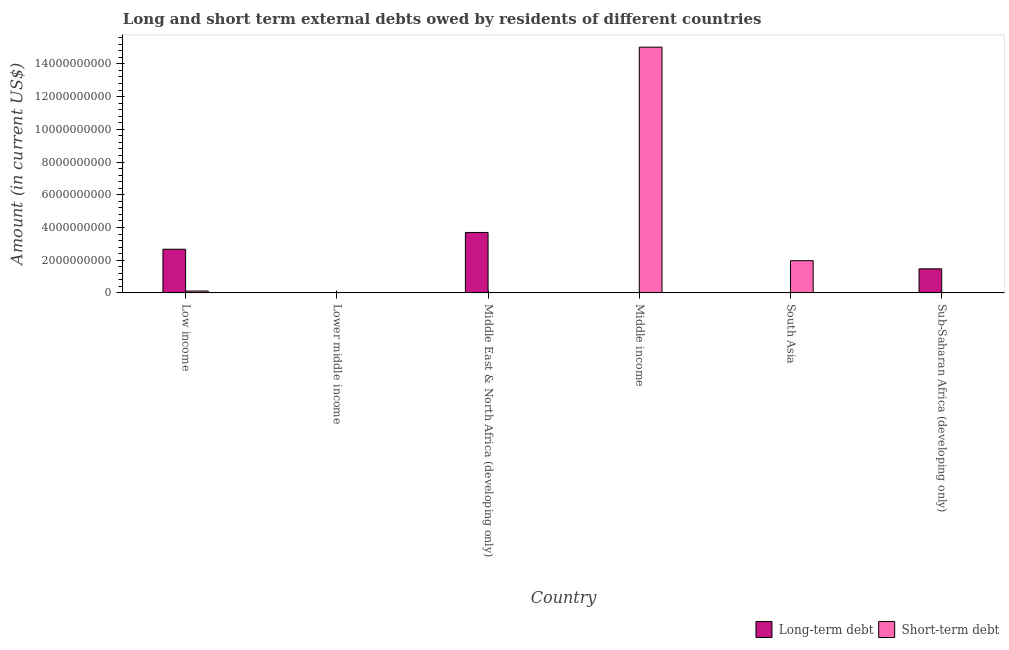How many different coloured bars are there?
Your answer should be compact. 2. Are the number of bars per tick equal to the number of legend labels?
Provide a succinct answer. No. How many bars are there on the 3rd tick from the right?
Provide a short and direct response. 1. In how many cases, is the number of bars for a given country not equal to the number of legend labels?
Make the answer very short. 5. What is the short-term debts owed by residents in Low income?
Keep it short and to the point. 1.17e+08. Across all countries, what is the maximum short-term debts owed by residents?
Keep it short and to the point. 1.50e+1. In which country was the short-term debts owed by residents maximum?
Your answer should be compact. Middle income. What is the total long-term debts owed by residents in the graph?
Offer a very short reply. 7.84e+09. What is the difference between the short-term debts owed by residents in Middle income and that in South Asia?
Ensure brevity in your answer.  1.30e+1. What is the difference between the short-term debts owed by residents in Lower middle income and the long-term debts owed by residents in South Asia?
Provide a short and direct response. 0. What is the average short-term debts owed by residents per country?
Provide a succinct answer. 2.85e+09. What is the difference between the short-term debts owed by residents and long-term debts owed by residents in Low income?
Keep it short and to the point. -2.55e+09. What is the ratio of the long-term debts owed by residents in Middle East & North Africa (developing only) to that in Sub-Saharan Africa (developing only)?
Your answer should be very brief. 2.51. What is the difference between the highest and the second highest long-term debts owed by residents?
Make the answer very short. 1.03e+09. What is the difference between the highest and the lowest short-term debts owed by residents?
Provide a short and direct response. 1.50e+1. Is the sum of the short-term debts owed by residents in Low income and South Asia greater than the maximum long-term debts owed by residents across all countries?
Offer a very short reply. No. How many countries are there in the graph?
Your response must be concise. 6. What is the difference between two consecutive major ticks on the Y-axis?
Ensure brevity in your answer.  2.00e+09. Are the values on the major ticks of Y-axis written in scientific E-notation?
Keep it short and to the point. No. Does the graph contain any zero values?
Ensure brevity in your answer.  Yes. What is the title of the graph?
Keep it short and to the point. Long and short term external debts owed by residents of different countries. What is the label or title of the X-axis?
Provide a short and direct response. Country. What is the Amount (in current US$) in Long-term debt in Low income?
Keep it short and to the point. 2.67e+09. What is the Amount (in current US$) in Short-term debt in Low income?
Keep it short and to the point. 1.17e+08. What is the Amount (in current US$) in Short-term debt in Lower middle income?
Your response must be concise. 0. What is the Amount (in current US$) in Long-term debt in Middle East & North Africa (developing only)?
Make the answer very short. 3.70e+09. What is the Amount (in current US$) in Short-term debt in Middle income?
Your response must be concise. 1.50e+1. What is the Amount (in current US$) of Short-term debt in South Asia?
Offer a very short reply. 1.97e+09. What is the Amount (in current US$) in Long-term debt in Sub-Saharan Africa (developing only)?
Ensure brevity in your answer.  1.47e+09. Across all countries, what is the maximum Amount (in current US$) of Long-term debt?
Provide a short and direct response. 3.70e+09. Across all countries, what is the maximum Amount (in current US$) of Short-term debt?
Make the answer very short. 1.50e+1. Across all countries, what is the minimum Amount (in current US$) in Long-term debt?
Keep it short and to the point. 0. What is the total Amount (in current US$) in Long-term debt in the graph?
Provide a succinct answer. 7.84e+09. What is the total Amount (in current US$) in Short-term debt in the graph?
Offer a very short reply. 1.71e+1. What is the difference between the Amount (in current US$) of Long-term debt in Low income and that in Middle East & North Africa (developing only)?
Your response must be concise. -1.03e+09. What is the difference between the Amount (in current US$) of Short-term debt in Low income and that in Middle income?
Provide a succinct answer. -1.49e+1. What is the difference between the Amount (in current US$) in Short-term debt in Low income and that in South Asia?
Your response must be concise. -1.85e+09. What is the difference between the Amount (in current US$) of Long-term debt in Low income and that in Sub-Saharan Africa (developing only)?
Give a very brief answer. 1.20e+09. What is the difference between the Amount (in current US$) of Long-term debt in Middle East & North Africa (developing only) and that in Sub-Saharan Africa (developing only)?
Keep it short and to the point. 2.22e+09. What is the difference between the Amount (in current US$) of Short-term debt in Middle income and that in South Asia?
Your response must be concise. 1.30e+1. What is the difference between the Amount (in current US$) of Long-term debt in Low income and the Amount (in current US$) of Short-term debt in Middle income?
Keep it short and to the point. -1.23e+1. What is the difference between the Amount (in current US$) in Long-term debt in Low income and the Amount (in current US$) in Short-term debt in South Asia?
Provide a short and direct response. 7.00e+08. What is the difference between the Amount (in current US$) of Long-term debt in Middle East & North Africa (developing only) and the Amount (in current US$) of Short-term debt in Middle income?
Offer a very short reply. -1.13e+1. What is the difference between the Amount (in current US$) of Long-term debt in Middle East & North Africa (developing only) and the Amount (in current US$) of Short-term debt in South Asia?
Ensure brevity in your answer.  1.73e+09. What is the average Amount (in current US$) of Long-term debt per country?
Keep it short and to the point. 1.31e+09. What is the average Amount (in current US$) in Short-term debt per country?
Make the answer very short. 2.85e+09. What is the difference between the Amount (in current US$) in Long-term debt and Amount (in current US$) in Short-term debt in Low income?
Keep it short and to the point. 2.55e+09. What is the ratio of the Amount (in current US$) of Long-term debt in Low income to that in Middle East & North Africa (developing only)?
Offer a terse response. 0.72. What is the ratio of the Amount (in current US$) in Short-term debt in Low income to that in Middle income?
Offer a terse response. 0.01. What is the ratio of the Amount (in current US$) of Short-term debt in Low income to that in South Asia?
Ensure brevity in your answer.  0.06. What is the ratio of the Amount (in current US$) in Long-term debt in Low income to that in Sub-Saharan Africa (developing only)?
Make the answer very short. 1.81. What is the ratio of the Amount (in current US$) of Long-term debt in Middle East & North Africa (developing only) to that in Sub-Saharan Africa (developing only)?
Your answer should be very brief. 2.51. What is the ratio of the Amount (in current US$) in Short-term debt in Middle income to that in South Asia?
Offer a terse response. 7.62. What is the difference between the highest and the second highest Amount (in current US$) in Long-term debt?
Keep it short and to the point. 1.03e+09. What is the difference between the highest and the second highest Amount (in current US$) in Short-term debt?
Offer a terse response. 1.30e+1. What is the difference between the highest and the lowest Amount (in current US$) in Long-term debt?
Your answer should be compact. 3.70e+09. What is the difference between the highest and the lowest Amount (in current US$) in Short-term debt?
Offer a terse response. 1.50e+1. 